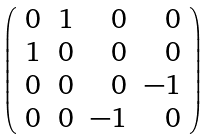<formula> <loc_0><loc_0><loc_500><loc_500>\left ( \begin{array} { r r r r } 0 & 1 & 0 & 0 \\ 1 & 0 & 0 & 0 \\ 0 & 0 & 0 & - 1 \\ 0 & 0 & - 1 & 0 \\ \end{array} \right )</formula> 